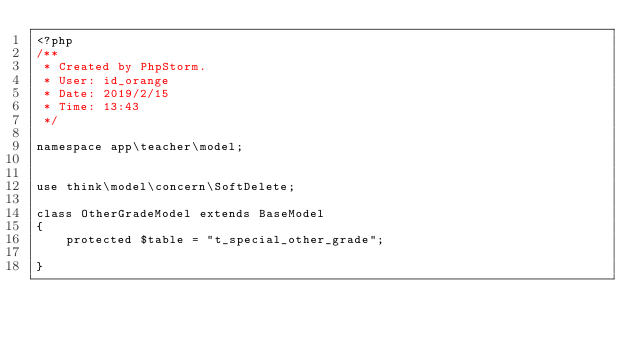<code> <loc_0><loc_0><loc_500><loc_500><_PHP_><?php
/**
 * Created by PhpStorm.
 * User: id_orange
 * Date: 2019/2/15
 * Time: 13:43
 */

namespace app\teacher\model;


use think\model\concern\SoftDelete;

class OtherGradeModel extends BaseModel
{
    protected $table = "t_special_other_grade";

}
</code> 